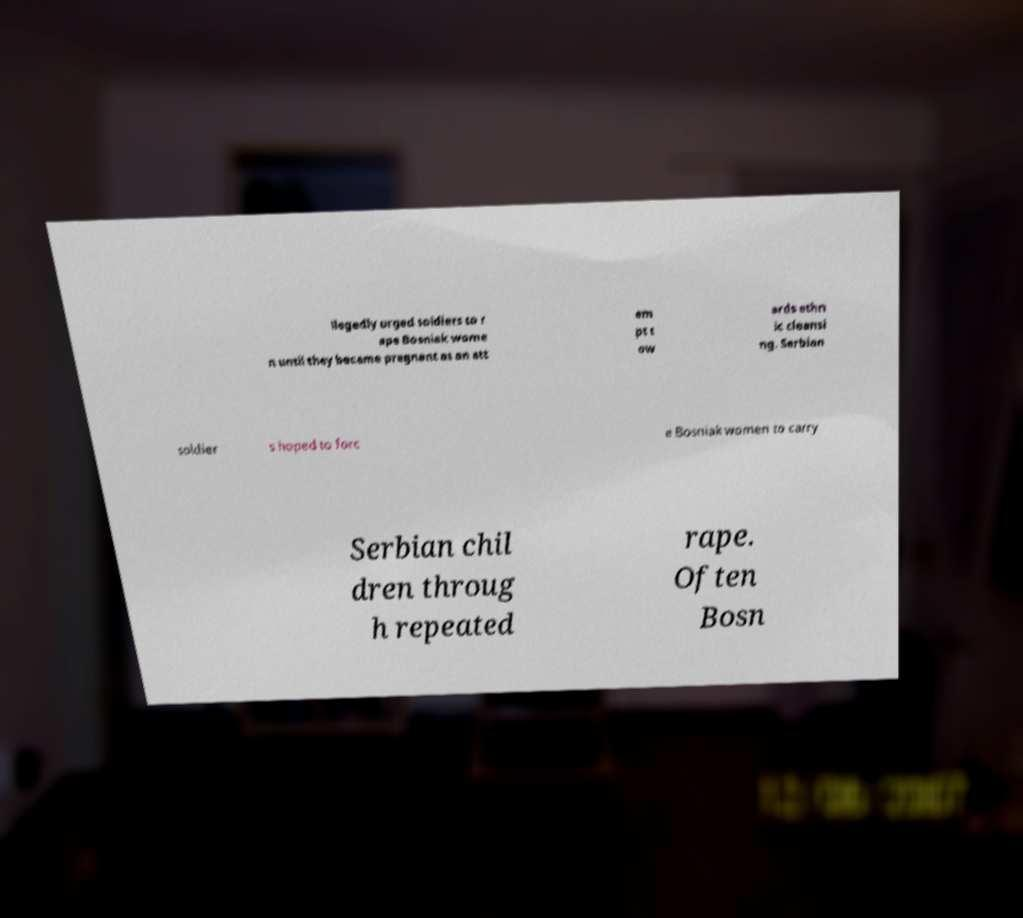What messages or text are displayed in this image? I need them in a readable, typed format. llegedly urged soldiers to r ape Bosniak wome n until they became pregnant as an att em pt t ow ards ethn ic cleansi ng. Serbian soldier s hoped to forc e Bosniak women to carry Serbian chil dren throug h repeated rape. Often Bosn 